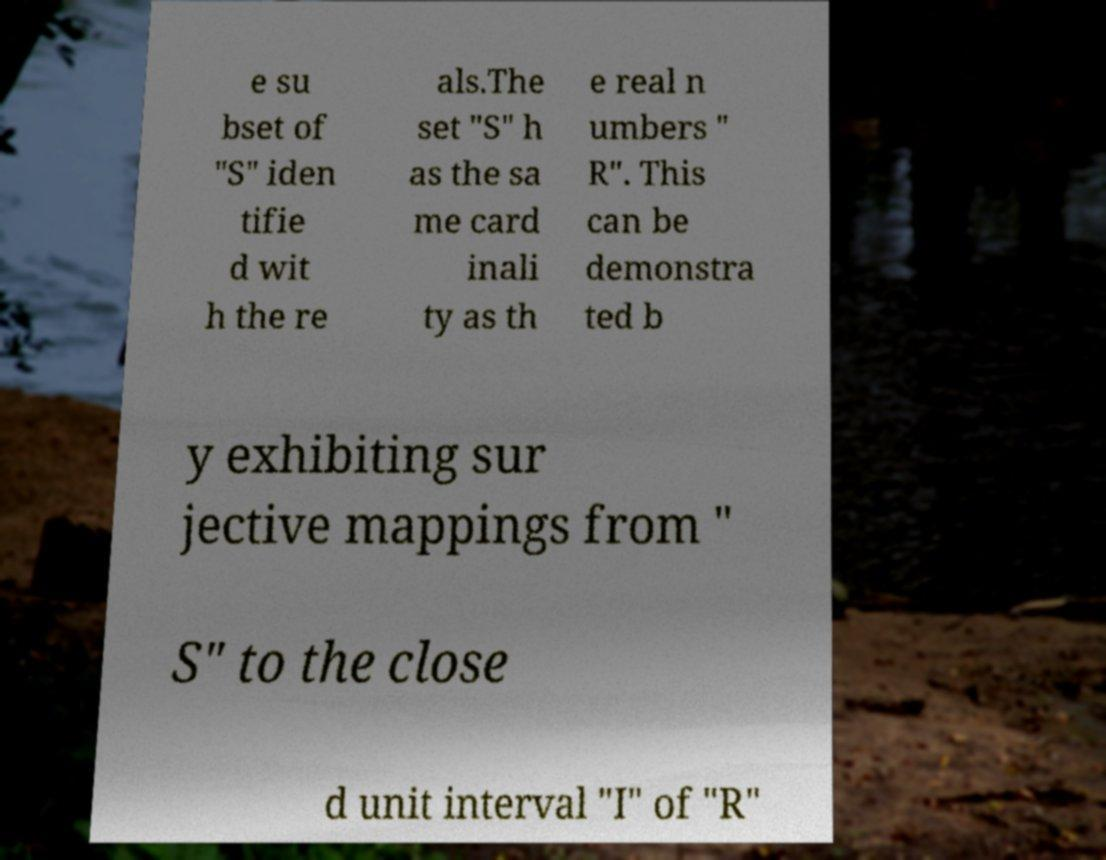Can you read and provide the text displayed in the image?This photo seems to have some interesting text. Can you extract and type it out for me? e su bset of "S" iden tifie d wit h the re als.The set "S" h as the sa me card inali ty as th e real n umbers " R". This can be demonstra ted b y exhibiting sur jective mappings from " S" to the close d unit interval "I" of "R" 